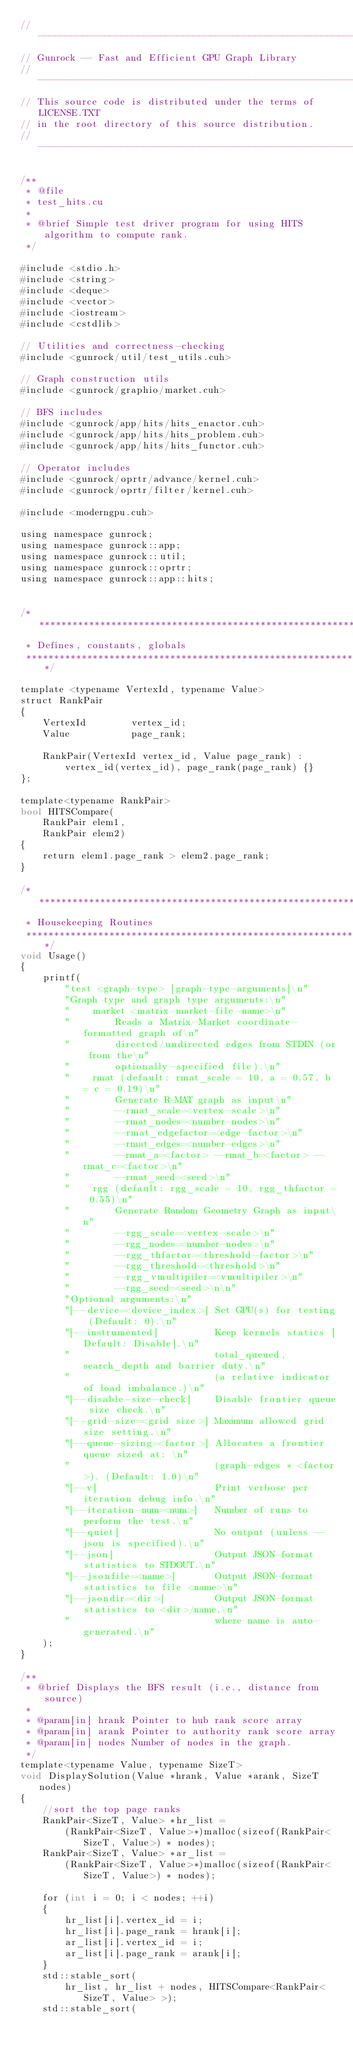Convert code to text. <code><loc_0><loc_0><loc_500><loc_500><_Cuda_>// ----------------------------------------------------------------
// Gunrock -- Fast and Efficient GPU Graph Library
// ----------------------------------------------------------------
// This source code is distributed under the terms of LICENSE.TXT
// in the root directory of this source distribution.
// ----------------------------------------------------------------

/**
 * @file
 * test_hits.cu
 *
 * @brief Simple test driver program for using HITS algorithm to compute rank.
 */

#include <stdio.h>
#include <string>
#include <deque>
#include <vector>
#include <iostream>
#include <cstdlib>

// Utilities and correctness-checking
#include <gunrock/util/test_utils.cuh>

// Graph construction utils
#include <gunrock/graphio/market.cuh>

// BFS includes
#include <gunrock/app/hits/hits_enactor.cuh>
#include <gunrock/app/hits/hits_problem.cuh>
#include <gunrock/app/hits/hits_functor.cuh>

// Operator includes
#include <gunrock/oprtr/advance/kernel.cuh>
#include <gunrock/oprtr/filter/kernel.cuh>

#include <moderngpu.cuh>

using namespace gunrock;
using namespace gunrock::app;
using namespace gunrock::util;
using namespace gunrock::oprtr;
using namespace gunrock::app::hits;


/******************************************************************************
 * Defines, constants, globals
 ******************************************************************************/

template <typename VertexId, typename Value>
struct RankPair
{
    VertexId        vertex_id;
    Value           page_rank;

    RankPair(VertexId vertex_id, Value page_rank) :
        vertex_id(vertex_id), page_rank(page_rank) {}
};

template<typename RankPair>
bool HITSCompare(
    RankPair elem1,
    RankPair elem2)
{
    return elem1.page_rank > elem2.page_rank;
}

/******************************************************************************
 * Housekeeping Routines
 ******************************************************************************/
void Usage()
{
    printf(
        "test <graph-type> [graph-type-arguments]\n"
        "Graph type and graph type arguments:\n"
        "    market <matrix-market-file-name>\n"
        "        Reads a Matrix-Market coordinate-formatted graph of\n"
        "        directed/undirected edges from STDIN (or from the\n"
        "        optionally-specified file).\n"
        "    rmat (default: rmat_scale = 10, a = 0.57, b = c = 0.19)\n"
        "        Generate R-MAT graph as input\n"
        "        --rmat_scale=<vertex-scale>\n"
        "        --rmat_nodes=<number-nodes>\n"
        "        --rmat_edgefactor=<edge-factor>\n"
        "        --rmat_edges=<number-edges>\n"
        "        --rmat_a=<factor> --rmat_b=<factor> --rmat_c=<factor>\n"
        "        --rmat_seed=<seed>\n"
        "    rgg (default: rgg_scale = 10, rgg_thfactor = 0.55)\n"
        "        Generate Random Geometry Graph as input\n"
        "        --rgg_scale=<vertex-scale>\n"
        "        --rgg_nodes=<number-nodes>\n"
        "        --rgg_thfactor=<threshold-factor>\n"
        "        --rgg_threshold=<threshold>\n"
        "        --rgg_vmultipiler=<vmultipiler>\n"
        "        --rgg_seed=<seed>\n\n"
        "Optional arguments:\n"
        "[--device=<device_index>] Set GPU(s) for testing (Default: 0).\n"
        "[--instrumented]          Keep kernels statics [Default: Disable].\n"
        "                          total_queued, search_depth and barrier duty.\n"
        "                          (a relative indicator of load imbalance.)\n"
        "[--disable-size-check]    Disable frontier queue size check.\n"
        "[--grid-size=<grid size>] Maximum allowed grid size setting.\n"
        "[--queue-sizing=<factor>] Allocates a frontier queue sized at: \n"
        "                          (graph-edges * <factor>). (Default: 1.0)\n"
        "[--v]                     Print verbose per iteration debug info.\n"
        "[--iteration-num=<num>]   Number of runs to perform the test.\n"
        "[--quiet]                 No output (unless --json is specified).\n"
        "[--json]                  Output JSON-format statistics to STDOUT.\n"
        "[--jsonfile=<name>]       Output JSON-format statistics to file <name>\n"
        "[--jsondir=<dir>]         Output JSON-format statistics to <dir>/name,\n"
        "                          where name is auto-generated.\n"
    );
}

/**
 * @brief Displays the BFS result (i.e., distance from source)
 *
 * @param[in] hrank Pointer to hub rank score array
 * @param[in] arank Pointer to authority rank score array
 * @param[in] nodes Number of nodes in the graph.
 */
template<typename Value, typename SizeT>
void DisplaySolution(Value *hrank, Value *arank, SizeT nodes)
{
    //sort the top page ranks
    RankPair<SizeT, Value> *hr_list =
        (RankPair<SizeT, Value>*)malloc(sizeof(RankPair<SizeT, Value>) * nodes);
    RankPair<SizeT, Value> *ar_list =
        (RankPair<SizeT, Value>*)malloc(sizeof(RankPair<SizeT, Value>) * nodes);

    for (int i = 0; i < nodes; ++i)
    {
        hr_list[i].vertex_id = i;
        hr_list[i].page_rank = hrank[i];
        ar_list[i].vertex_id = i;
        ar_list[i].page_rank = arank[i];
    }
    std::stable_sort(
        hr_list, hr_list + nodes, HITSCompare<RankPair<SizeT, Value> >);
    std::stable_sort(</code> 